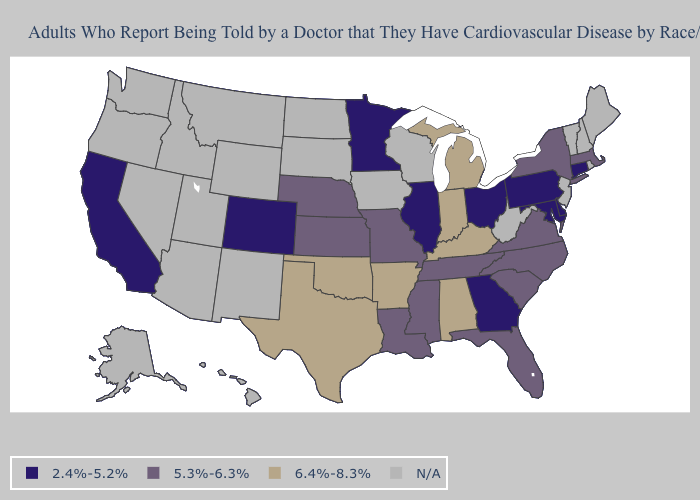Name the states that have a value in the range N/A?
Write a very short answer. Alaska, Arizona, Hawaii, Idaho, Iowa, Maine, Montana, Nevada, New Hampshire, New Jersey, New Mexico, North Dakota, Oregon, Rhode Island, South Dakota, Utah, Vermont, Washington, West Virginia, Wisconsin, Wyoming. Which states have the lowest value in the USA?
Quick response, please. California, Colorado, Connecticut, Delaware, Georgia, Illinois, Maryland, Minnesota, Ohio, Pennsylvania. Name the states that have a value in the range 2.4%-5.2%?
Keep it brief. California, Colorado, Connecticut, Delaware, Georgia, Illinois, Maryland, Minnesota, Ohio, Pennsylvania. How many symbols are there in the legend?
Short answer required. 4. What is the highest value in the Northeast ?
Be succinct. 5.3%-6.3%. What is the value of South Dakota?
Give a very brief answer. N/A. Among the states that border West Virginia , does Kentucky have the highest value?
Give a very brief answer. Yes. What is the value of Illinois?
Keep it brief. 2.4%-5.2%. How many symbols are there in the legend?
Concise answer only. 4. Does Florida have the highest value in the USA?
Short answer required. No. Which states have the lowest value in the USA?
Give a very brief answer. California, Colorado, Connecticut, Delaware, Georgia, Illinois, Maryland, Minnesota, Ohio, Pennsylvania. Name the states that have a value in the range 2.4%-5.2%?
Give a very brief answer. California, Colorado, Connecticut, Delaware, Georgia, Illinois, Maryland, Minnesota, Ohio, Pennsylvania. Name the states that have a value in the range 2.4%-5.2%?
Keep it brief. California, Colorado, Connecticut, Delaware, Georgia, Illinois, Maryland, Minnesota, Ohio, Pennsylvania. Name the states that have a value in the range 2.4%-5.2%?
Quick response, please. California, Colorado, Connecticut, Delaware, Georgia, Illinois, Maryland, Minnesota, Ohio, Pennsylvania. 